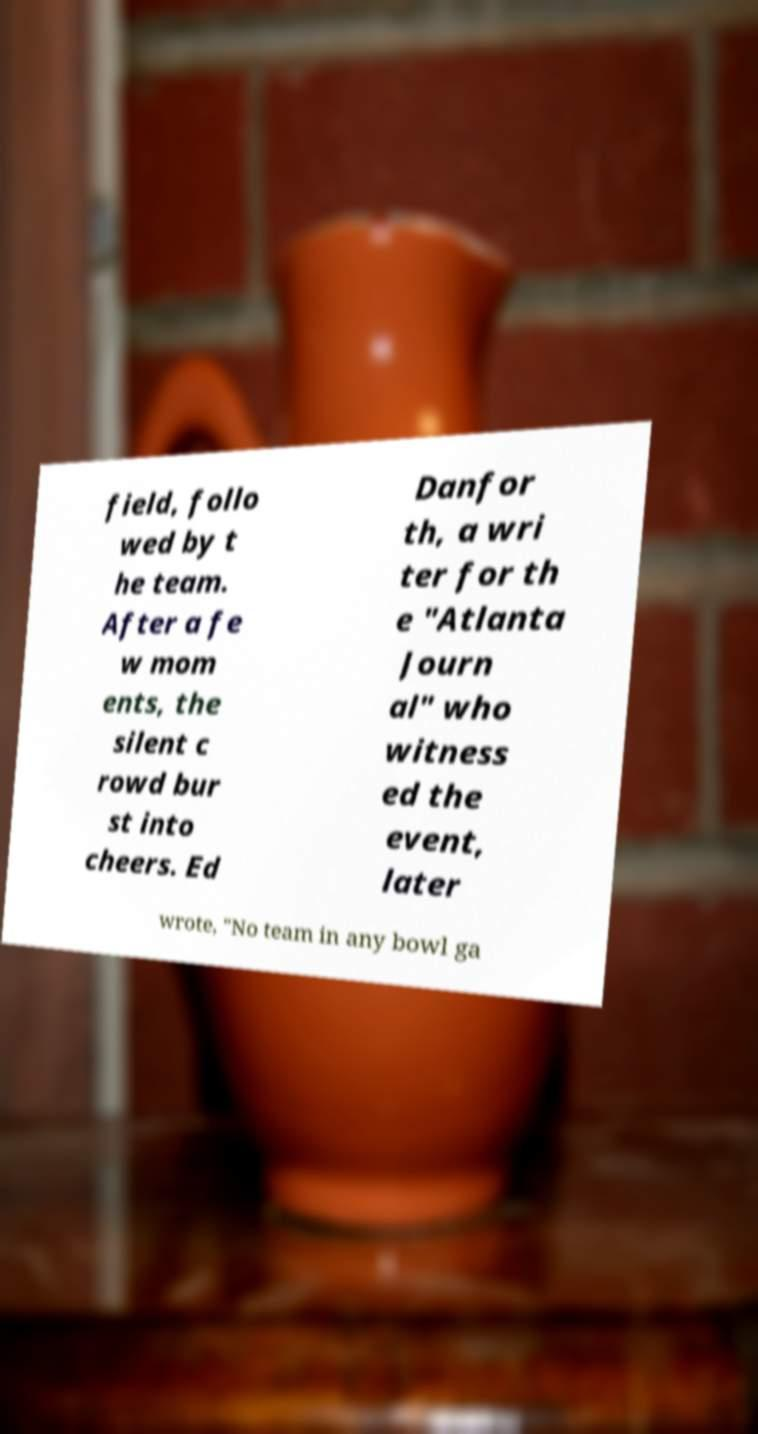For documentation purposes, I need the text within this image transcribed. Could you provide that? field, follo wed by t he team. After a fe w mom ents, the silent c rowd bur st into cheers. Ed Danfor th, a wri ter for th e "Atlanta Journ al" who witness ed the event, later wrote, "No team in any bowl ga 